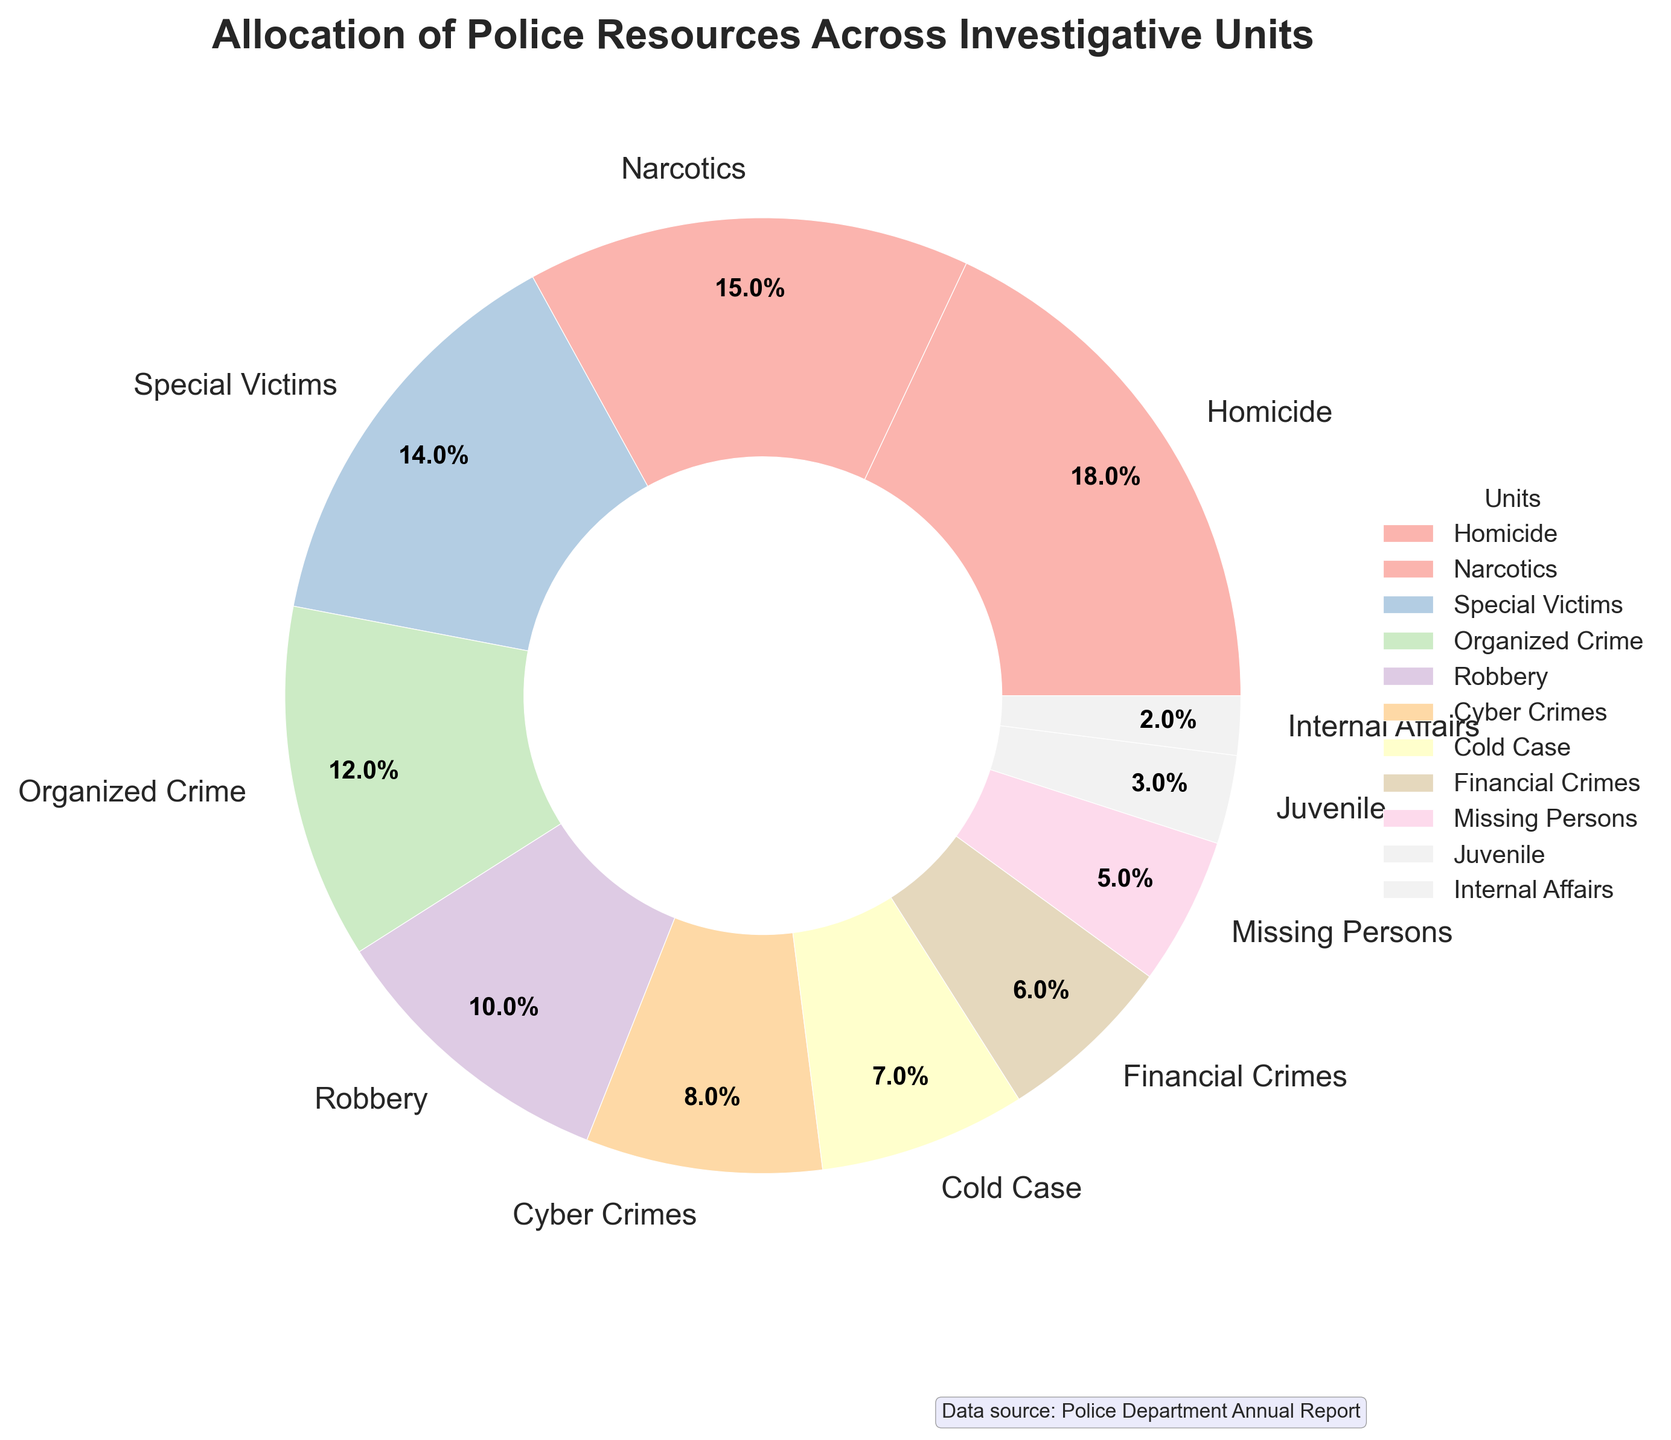Which unit receives the largest allocation of police resources? From the pie chart, the largest wedge is labeled "Homicide", which indicates it receives the largest allocation of resources.
Answer: Homicide What is the combined percentage of resources allocated to Organized Crime and Narcotics units? The percentage for Organized Crime is 12% and for Narcotics is 15%. Adding them together, 12% + 15% = 27%.
Answer: 27% How does the allocation for Cyber Crimes compare to that of Cold Case? The pie chart shows that Cyber Crimes is allocated 8% and Cold Case is allocated 7%. Cyber Crimes receives a higher percentage of resources compared to Cold Case.
Answer: Cyber Crimes receives more What is the total percentage of resources allocated to units with less than 5% allocation? The units with less than 5% are Juvenile (3%) and Internal Affairs (2%). Adding them together, 3% + 2% = 5%.
Answer: 5% Which color represents the Special Victims unit on the pie chart? Each unit has a different color on the pie chart. Special Victims is identified on the pie chart by looking at the color next to the "Special Victims" label in the legend, which is a shade from the Pastel1 colormap.
Answer: A pastel color shade Are there more resources allocated to Special Victims or Financial Crimes? Special Victims has 14% while Financial Crimes has 6%. Therefore, Special Victims is allocated more resources.
Answer: Special Victims What is the difference in resource allocation between Missing Persons and Juvenile units? Missing Persons is allocated 5% and Juvenile is allocated 3%. The difference is 5% - 3% = 2%.
Answer: 2% Which units combined receive exactly half of the overall police resources? Adding the percentages of the largest units until their sum reaches 50%: Homicide (18%) + Narcotics (15%) + Special Victims (14%) + Organized Crime (12%) exceeds 50%. However, choosing Homicide, Narcotics, and Special Victims, we get 18% + 15% + 14% = 47% close but not exactly half. The appropriate breaking point is chosen individually for sum 50% which can be seen splitting among individual ranges. Thus, a meticulous examination of smaller units might be necessary repeatedly combining pattern.
Answer: A more detailed inspection would yield exact units What percentage of resources is allocated to units primarily dealing with financial or digital crimes (Financial Crimes and Cyber Crimes)? Financial Crimes is allocated 6% and Cyber Crimes is allocated 8%. Adding them together, 6% + 8% = 14%.
Answer: 14% Which three smallest units account for the smallest total percentage of resources? The three smallest units are Internal Affairs (2%), Juvenile (3%), and Missing Persons (5%). Adding them together, 2% + 3% + 5% = 10%.
Answer: Internal Affairs, Juvenile, Missing Persons 